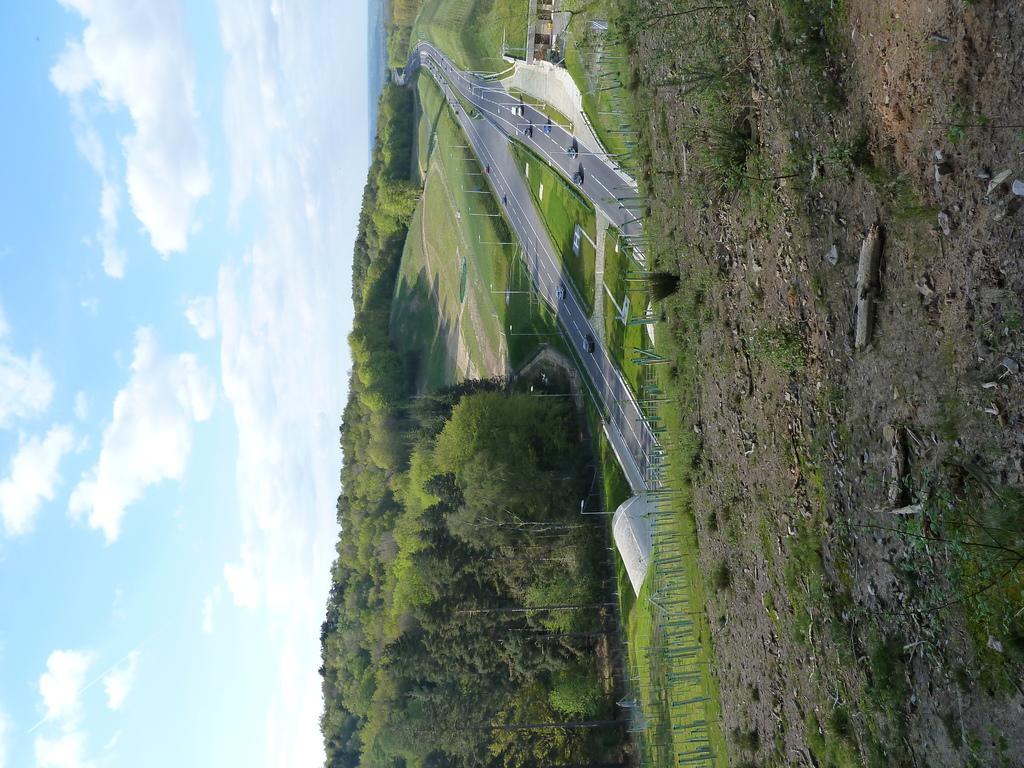Could you give a brief overview of what you see in this image? In this image we can see a road on which there are vehicles. There are poles. There are trees. In the background of the image there is sky and clouds. At the bottom of the image there is soil. 